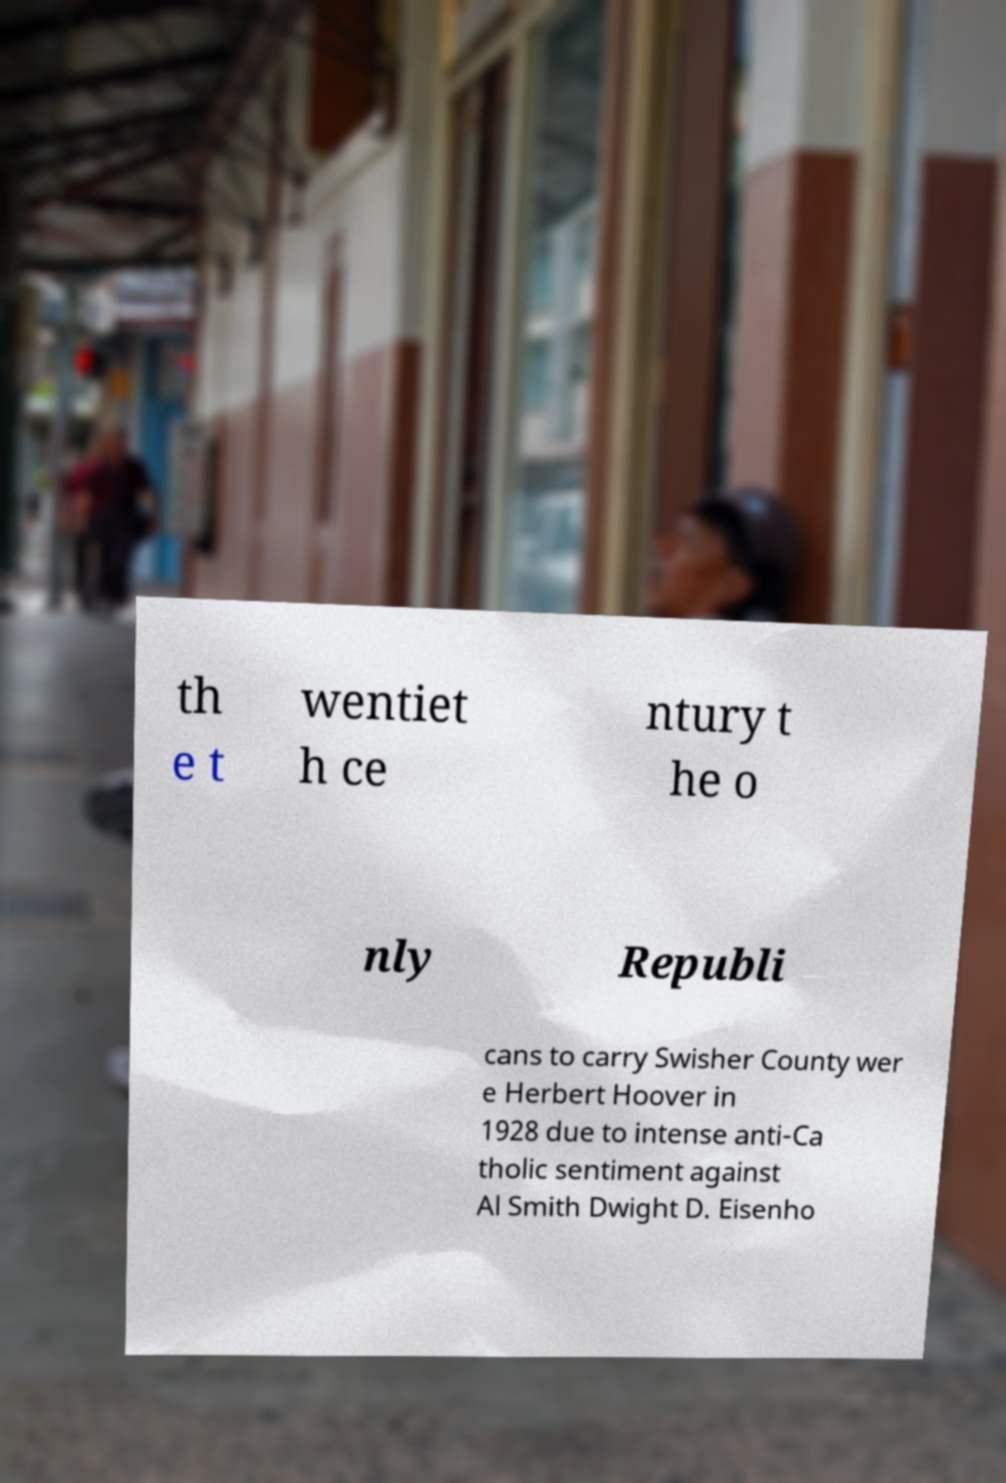Could you extract and type out the text from this image? th e t wentiet h ce ntury t he o nly Republi cans to carry Swisher County wer e Herbert Hoover in 1928 due to intense anti-Ca tholic sentiment against Al Smith Dwight D. Eisenho 